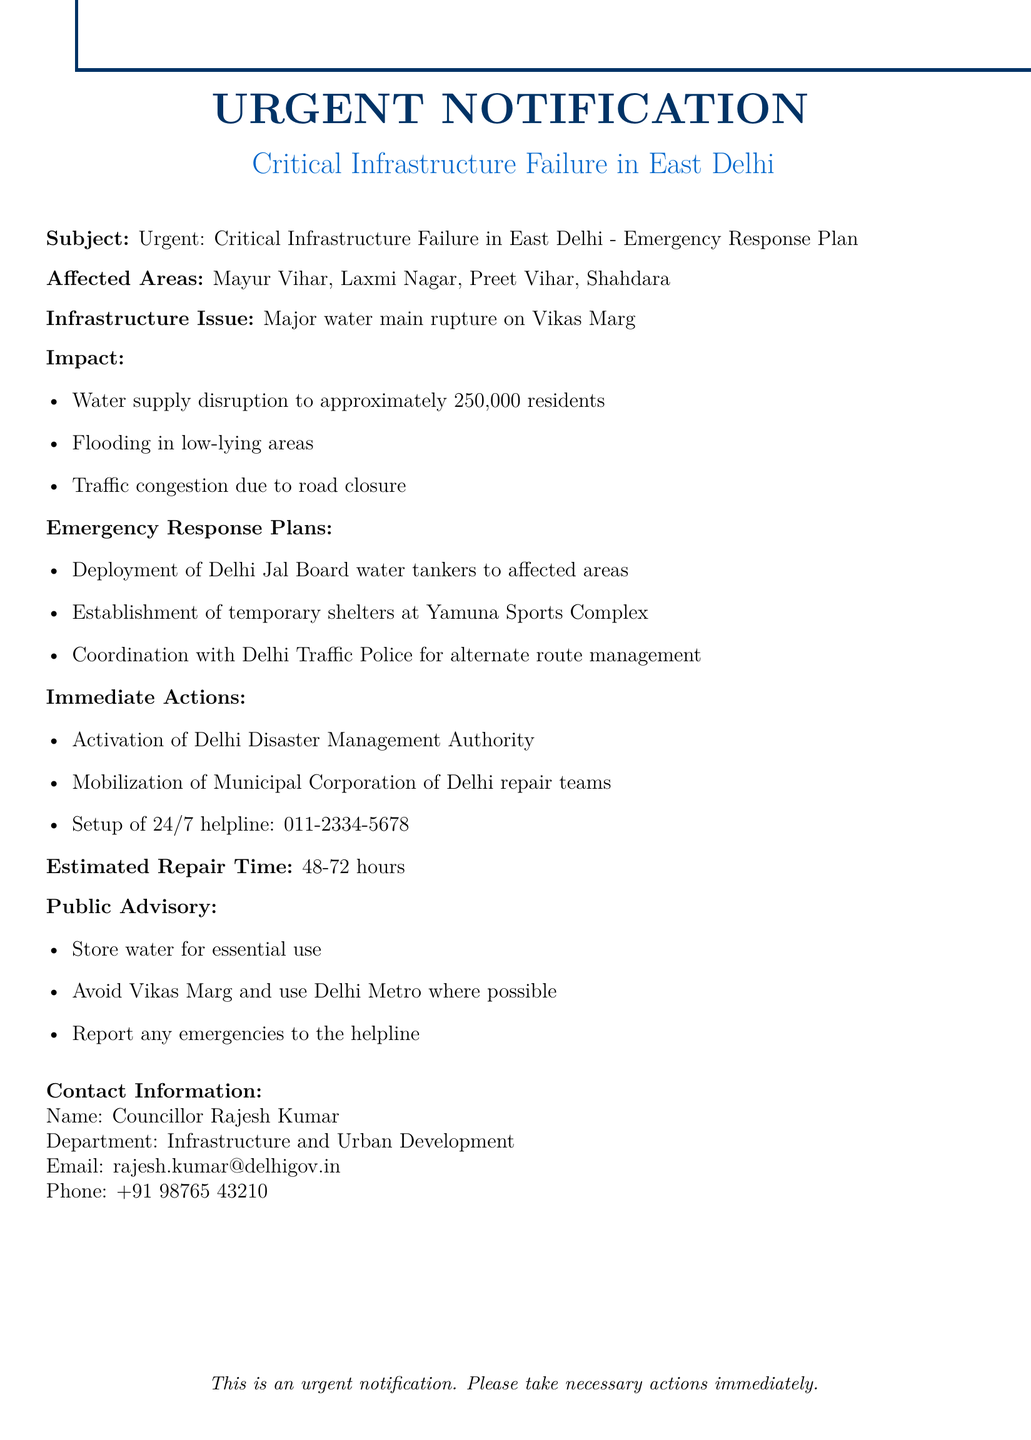What is the subject of the email? The subject line provides a brief overview of the email's content, which mentions a critical infrastructure failure and emergency response plan.
Answer: Urgent: Critical Infrastructure Failure in East Delhi - Emergency Response Plan Which areas are affected by the infrastructure issue? The affected areas are listed in the document, indicating where the impact of the infrastructure failure is being felt.
Answer: Mayur Vihar, Laxmi Nagar, Preet Vihar, Shahdara What is the estimated repair time for the infrastructure issue? The estimated repair time is specified to inform stakeholders of how long the repairs are expected to take.
Answer: 48-72 hours What immediate action has been taken regarding management? The document outlines immediate actions for addressing the crisis, including the activation of governmental bodies.
Answer: Activation of Delhi Disaster Management Authority How many residents are impacted by the water supply disruption? The number of residents impacted is included to highlight the scale of the emergency.
Answer: Approximately 250,000 residents Which temporary shelter location is provided for affected residents? The document specifies a particular location for temporary shelter to support displaced residents.
Answer: Yamuna Sports Complex What is the contact number for reporting emergencies? The helpline number for emergencies is explicitly stated in the document as part of the immediate response plan.
Answer: 011-2334-5678 What are residents advised to do with water? The public advisory gives specific guidance on water usage in light of the supply disruption.
Answer: Store water for essential use Why should residents avoid using Vikas Marg? The document indicates the reason for avoiding this road, connected to the infrastructure issue and its consequences.
Answer: Traffic congestion due to road closure 